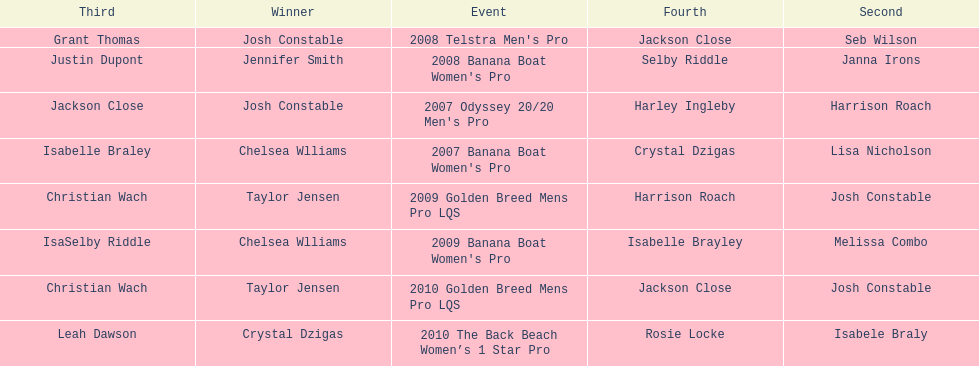In what event did chelsea williams win her first title? 2007 Banana Boat Women's Pro. 